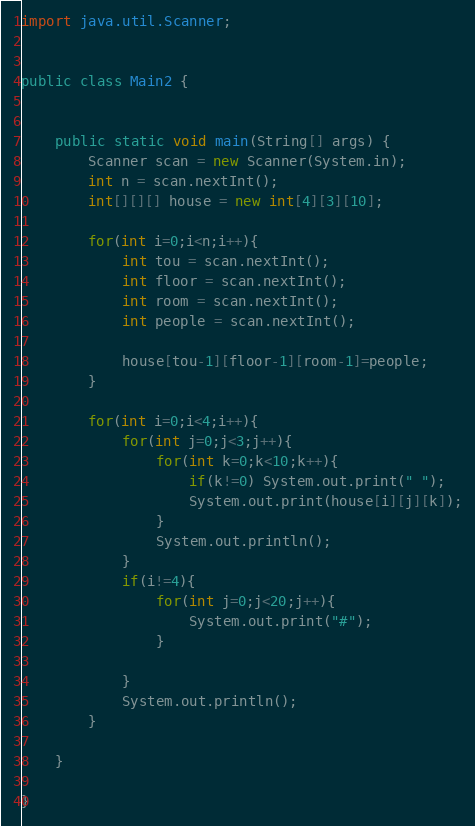<code> <loc_0><loc_0><loc_500><loc_500><_Java_>import java.util.Scanner;


public class Main2 {


	public static void main(String[] args) {
		Scanner scan = new Scanner(System.in);
		int n = scan.nextInt();
		int[][][] house = new int[4][3][10];

		for(int i=0;i<n;i++){
			int tou = scan.nextInt();
			int floor = scan.nextInt();
			int room = scan.nextInt();
			int people = scan.nextInt();

			house[tou-1][floor-1][room-1]=people;
		}

		for(int i=0;i<4;i++){
			for(int j=0;j<3;j++){
				for(int k=0;k<10;k++){
					if(k!=0) System.out.print(" ");
					System.out.print(house[i][j][k]);
				}
				System.out.println();
			}
			if(i!=4){
				for(int j=0;j<20;j++){
					System.out.print("#");
				}
				
			}
			System.out.println();
		}

	}

}</code> 